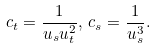<formula> <loc_0><loc_0><loc_500><loc_500>c _ { t } = \frac { 1 } { u _ { s } u _ { t } ^ { 2 } } , \, c _ { s } = \frac { 1 } { u _ { s } ^ { 3 } } .</formula> 